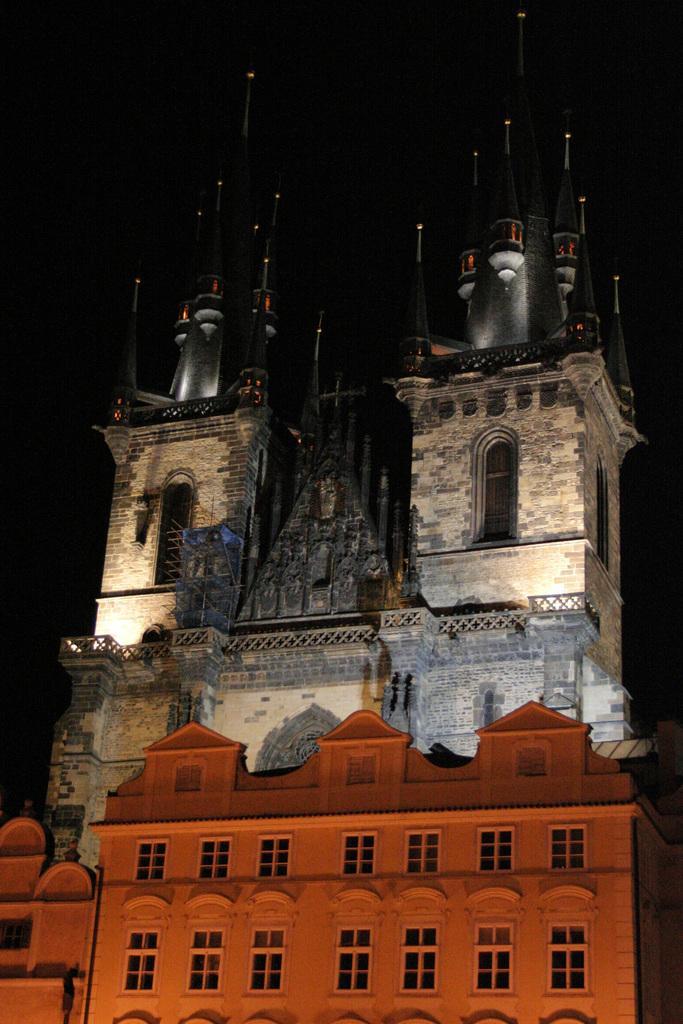How would you summarize this image in a sentence or two? In the center of the image we can see buildings, windows and railings. And we can see the dark background. 